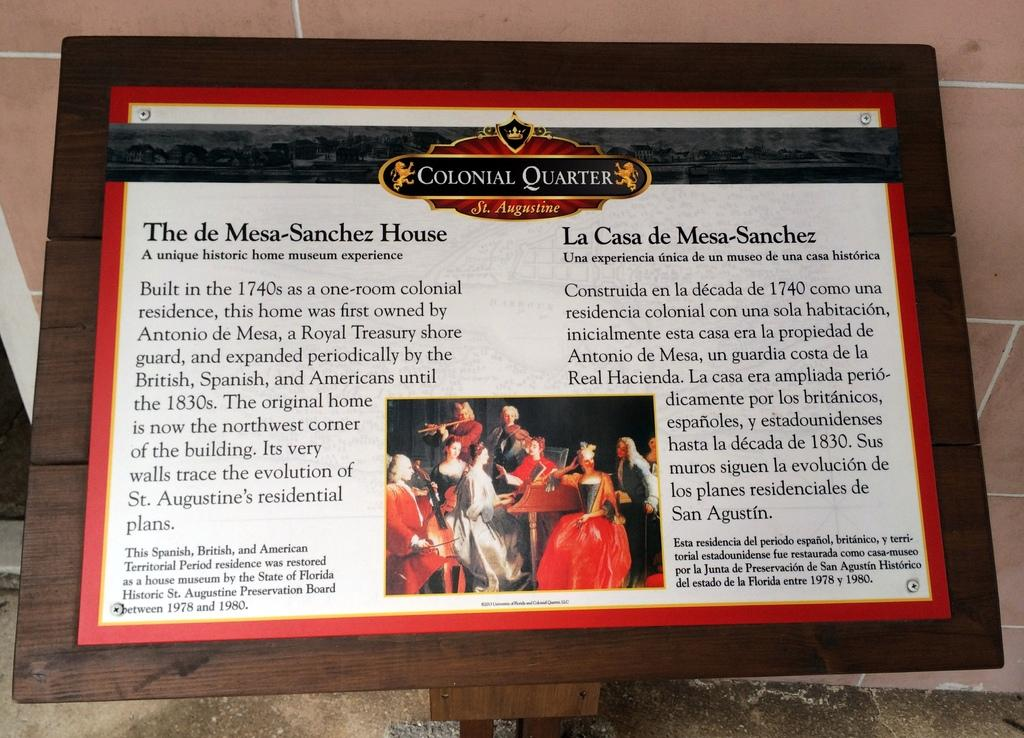<image>
Give a short and clear explanation of the subsequent image. Colonial Quarter is sharing information in text about the Mesa-Sanchez house. 